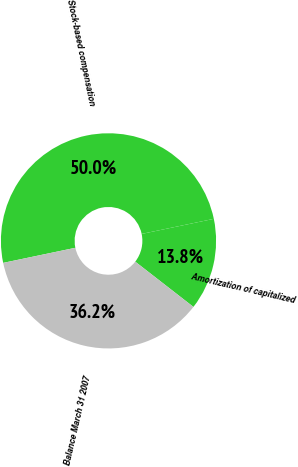Convert chart. <chart><loc_0><loc_0><loc_500><loc_500><pie_chart><fcel>Stock-based compensation<fcel>Amortization of capitalized<fcel>Balance March 31 2007<nl><fcel>50.0%<fcel>13.8%<fcel>36.2%<nl></chart> 